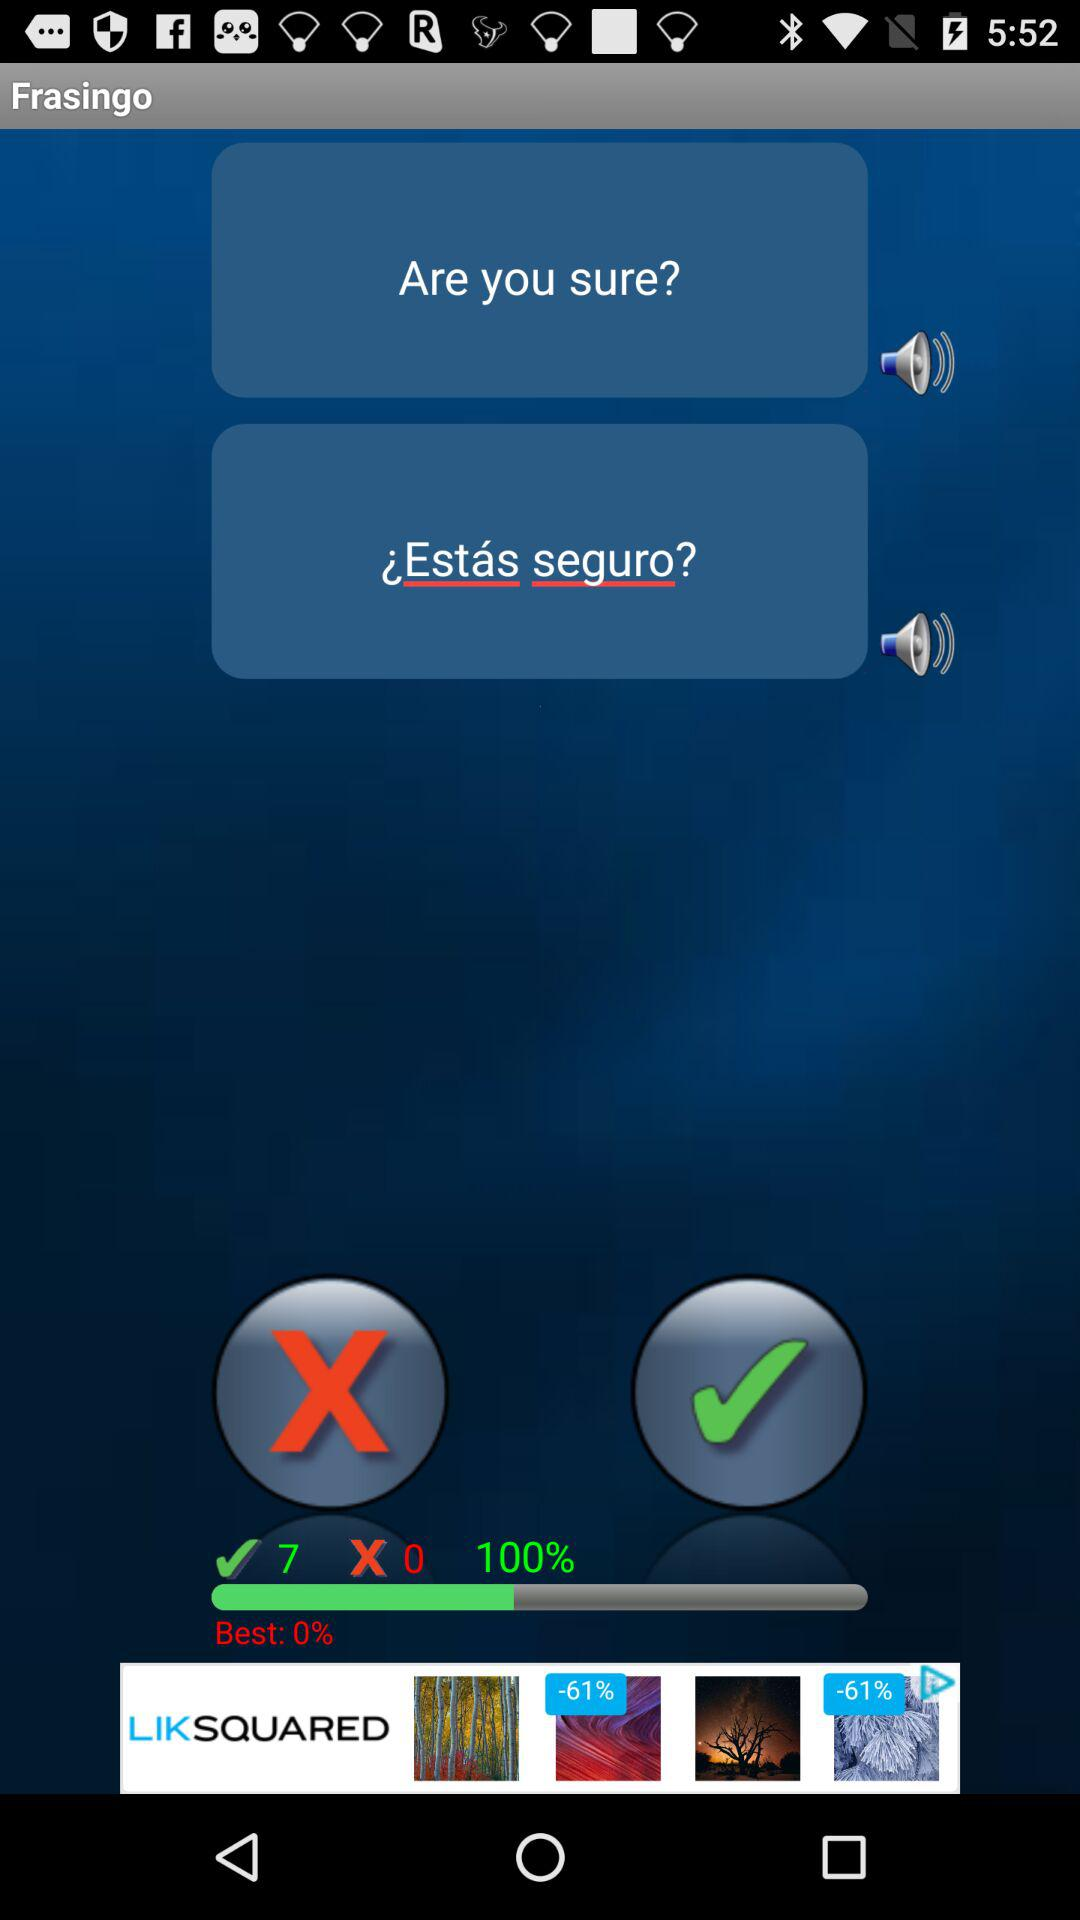Which language is the translation?
When the provided information is insufficient, respond with <no answer>. <no answer> 